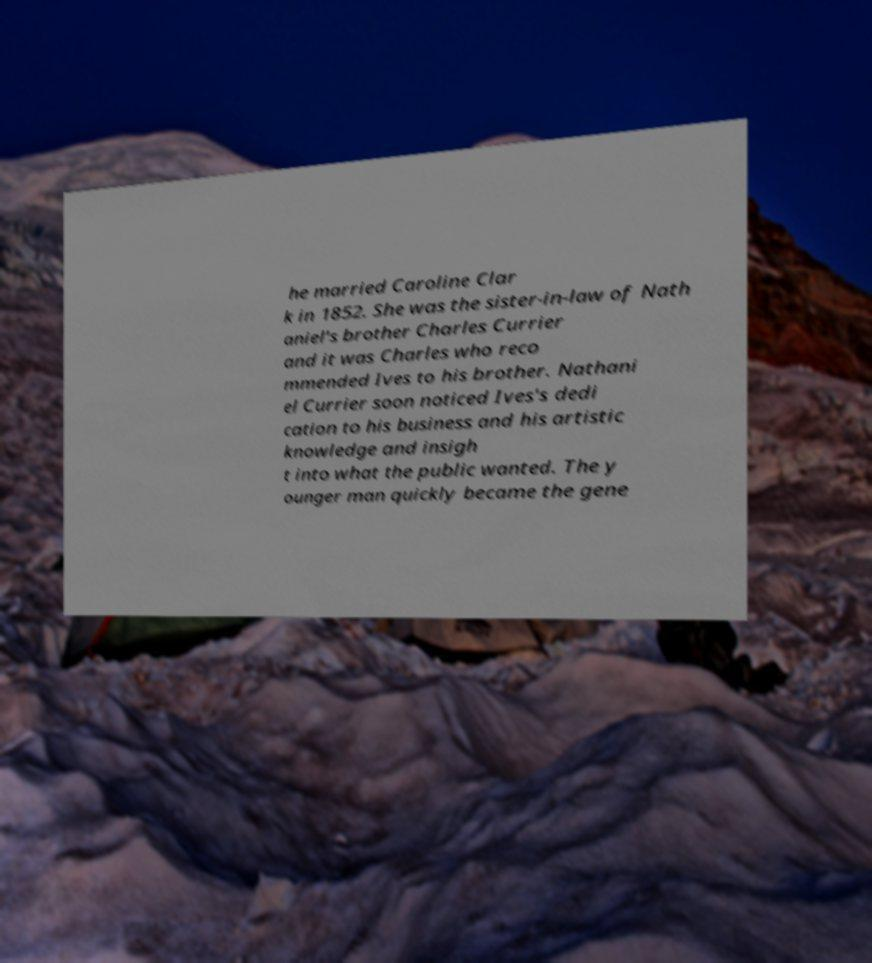What messages or text are displayed in this image? I need them in a readable, typed format. he married Caroline Clar k in 1852. She was the sister-in-law of Nath aniel's brother Charles Currier and it was Charles who reco mmended Ives to his brother. Nathani el Currier soon noticed Ives's dedi cation to his business and his artistic knowledge and insigh t into what the public wanted. The y ounger man quickly became the gene 